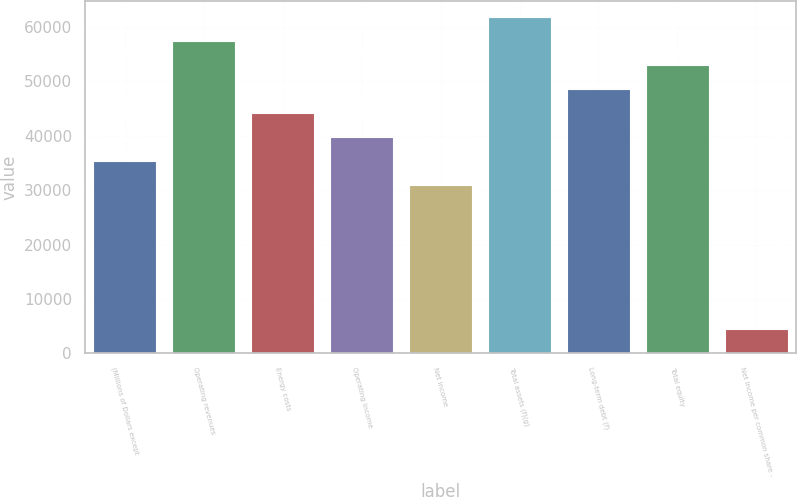Convert chart. <chart><loc_0><loc_0><loc_500><loc_500><bar_chart><fcel>(Millions of Dollars except<fcel>Operating revenues<fcel>Energy costs<fcel>Operating income<fcel>Net income<fcel>Total assets (f)(g)<fcel>Long-term debt (f)<fcel>Total equity<fcel>Net Income per common share -<nl><fcel>35257.3<fcel>57291.6<fcel>44071<fcel>39664.2<fcel>30850.5<fcel>61698.4<fcel>48477.9<fcel>52884.7<fcel>4409.37<nl></chart> 